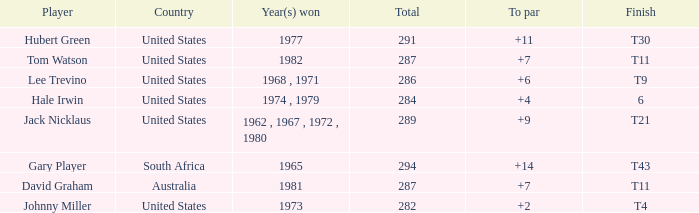WHAT IS THE TOTAL, OF A TO PAR FOR HUBERT GREEN, AND A TOTAL LARGER THAN 291? 0.0. 